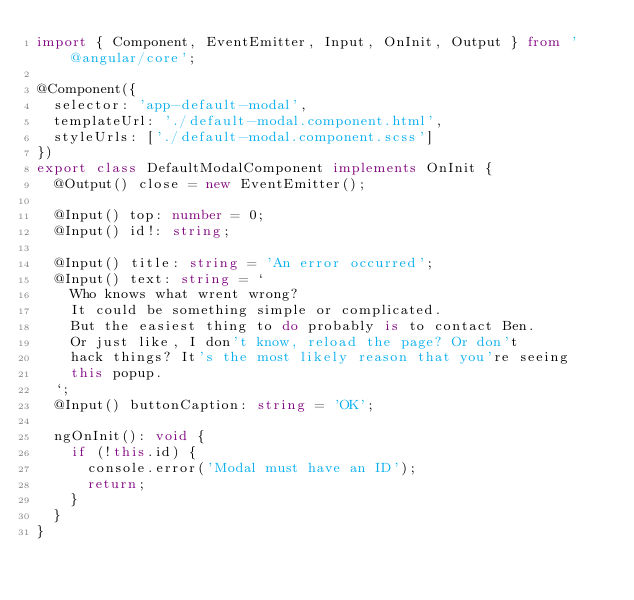Convert code to text. <code><loc_0><loc_0><loc_500><loc_500><_TypeScript_>import { Component, EventEmitter, Input, OnInit, Output } from '@angular/core';

@Component({
  selector: 'app-default-modal',
  templateUrl: './default-modal.component.html',
  styleUrls: ['./default-modal.component.scss']
})
export class DefaultModalComponent implements OnInit {
  @Output() close = new EventEmitter();

  @Input() top: number = 0;
  @Input() id!: string;

  @Input() title: string = 'An error occurred';
  @Input() text: string = `
    Who knows what wrent wrong?
    It could be something simple or complicated.
    But the easiest thing to do probably is to contact Ben.
    Or just like, I don't know, reload the page? Or don't
    hack things? It's the most likely reason that you're seeing
    this popup.
  `;
  @Input() buttonCaption: string = 'OK';

  ngOnInit(): void {
    if (!this.id) {
      console.error('Modal must have an ID');
      return;
    }
  }
}
</code> 